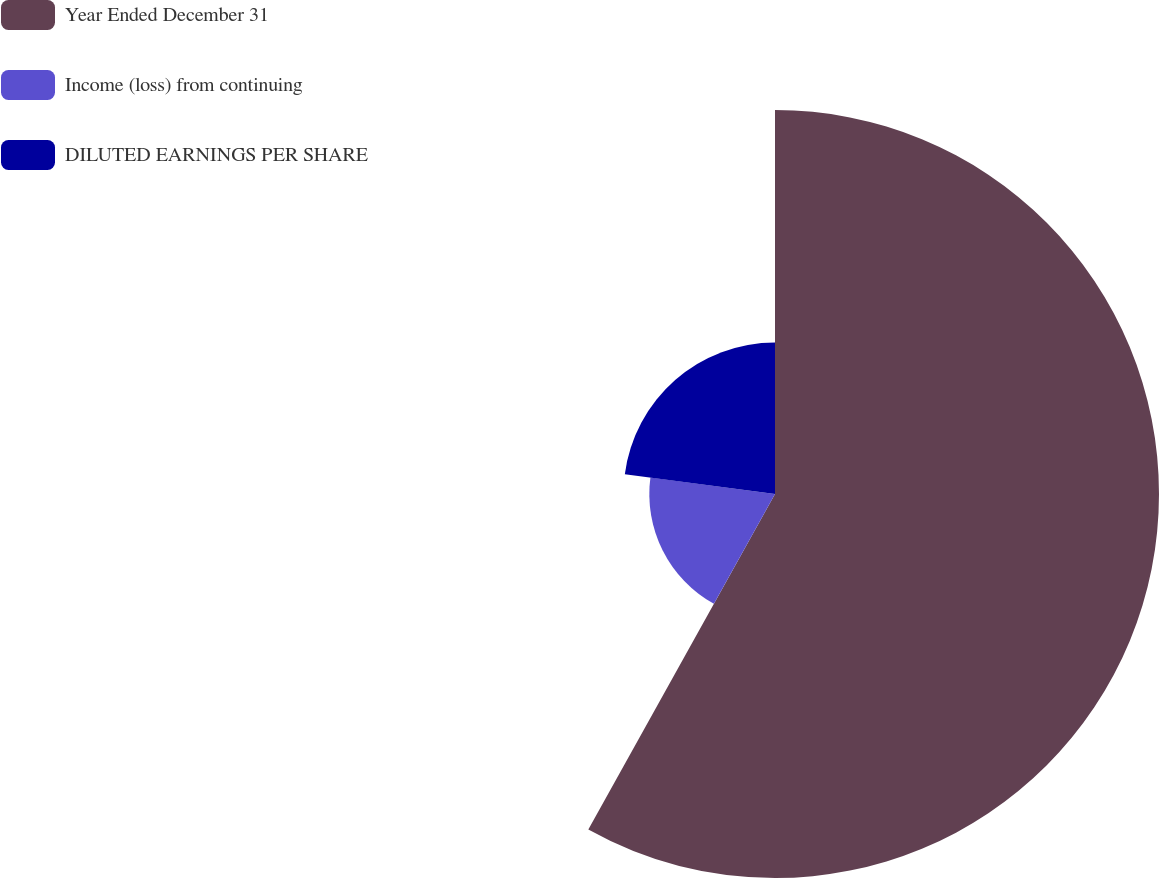<chart> <loc_0><loc_0><loc_500><loc_500><pie_chart><fcel>Year Ended December 31<fcel>Income (loss) from continuing<fcel>DILUTED EARNINGS PER SHARE<nl><fcel>58.08%<fcel>19.01%<fcel>22.91%<nl></chart> 